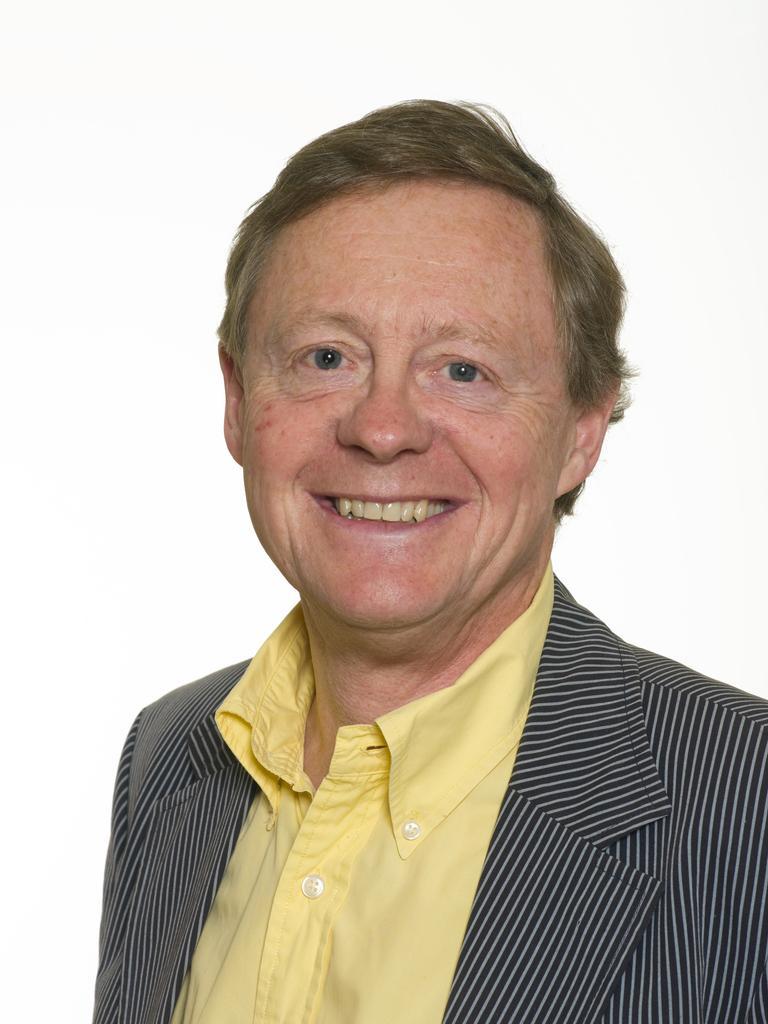Could you give a brief overview of what you see in this image? In this picture we can see a man wearing a blazer, shirt and he is smiling. Background portion of the picture is in white color. 